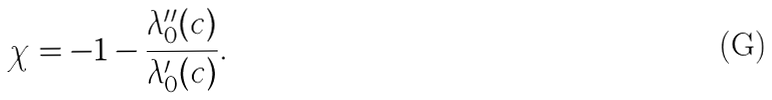Convert formula to latex. <formula><loc_0><loc_0><loc_500><loc_500>\chi = - 1 - \frac { \lambda _ { 0 } ^ { \prime \prime } ( c ) } { \lambda _ { 0 } ^ { \prime } ( c ) } .</formula> 